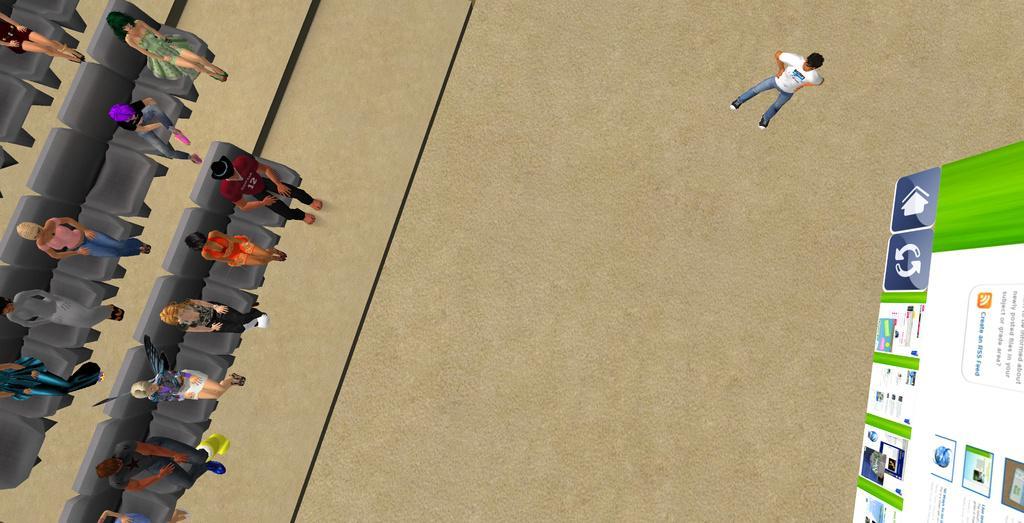How would you summarize this image in a sentence or two? In this image I can see the animated picture and I can also see the person standing and the person is wearing white and blue color dress and I can also see the screen in green and white color and I can see something written on the screen. 